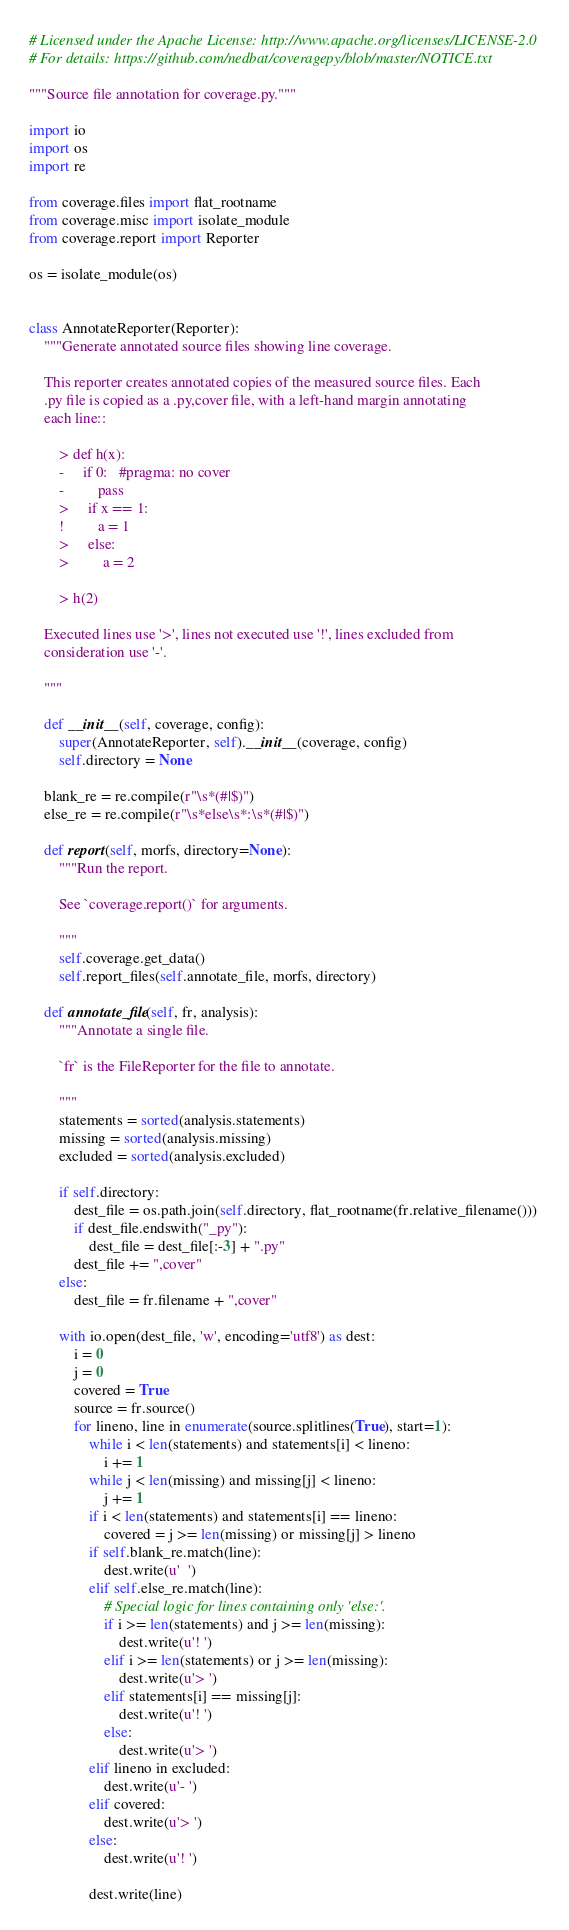Convert code to text. <code><loc_0><loc_0><loc_500><loc_500><_Python_># Licensed under the Apache License: http://www.apache.org/licenses/LICENSE-2.0
# For details: https://github.com/nedbat/coveragepy/blob/master/NOTICE.txt

"""Source file annotation for coverage.py."""

import io
import os
import re

from coverage.files import flat_rootname
from coverage.misc import isolate_module
from coverage.report import Reporter

os = isolate_module(os)


class AnnotateReporter(Reporter):
    """Generate annotated source files showing line coverage.

    This reporter creates annotated copies of the measured source files. Each
    .py file is copied as a .py,cover file, with a left-hand margin annotating
    each line::

        > def h(x):
        -     if 0:   #pragma: no cover
        -         pass
        >     if x == 1:
        !         a = 1
        >     else:
        >         a = 2

        > h(2)

    Executed lines use '>', lines not executed use '!', lines excluded from
    consideration use '-'.

    """

    def __init__(self, coverage, config):
        super(AnnotateReporter, self).__init__(coverage, config)
        self.directory = None

    blank_re = re.compile(r"\s*(#|$)")
    else_re = re.compile(r"\s*else\s*:\s*(#|$)")

    def report(self, morfs, directory=None):
        """Run the report.

        See `coverage.report()` for arguments.

        """
        self.coverage.get_data()
        self.report_files(self.annotate_file, morfs, directory)

    def annotate_file(self, fr, analysis):
        """Annotate a single file.

        `fr` is the FileReporter for the file to annotate.

        """
        statements = sorted(analysis.statements)
        missing = sorted(analysis.missing)
        excluded = sorted(analysis.excluded)

        if self.directory:
            dest_file = os.path.join(self.directory, flat_rootname(fr.relative_filename()))
            if dest_file.endswith("_py"):
                dest_file = dest_file[:-3] + ".py"
            dest_file += ",cover"
        else:
            dest_file = fr.filename + ",cover"

        with io.open(dest_file, 'w', encoding='utf8') as dest:
            i = 0
            j = 0
            covered = True
            source = fr.source()
            for lineno, line in enumerate(source.splitlines(True), start=1):
                while i < len(statements) and statements[i] < lineno:
                    i += 1
                while j < len(missing) and missing[j] < lineno:
                    j += 1
                if i < len(statements) and statements[i] == lineno:
                    covered = j >= len(missing) or missing[j] > lineno
                if self.blank_re.match(line):
                    dest.write(u'  ')
                elif self.else_re.match(line):
                    # Special logic for lines containing only 'else:'.
                    if i >= len(statements) and j >= len(missing):
                        dest.write(u'! ')
                    elif i >= len(statements) or j >= len(missing):
                        dest.write(u'> ')
                    elif statements[i] == missing[j]:
                        dest.write(u'! ')
                    else:
                        dest.write(u'> ')
                elif lineno in excluded:
                    dest.write(u'- ')
                elif covered:
                    dest.write(u'> ')
                else:
                    dest.write(u'! ')

                dest.write(line)
</code> 